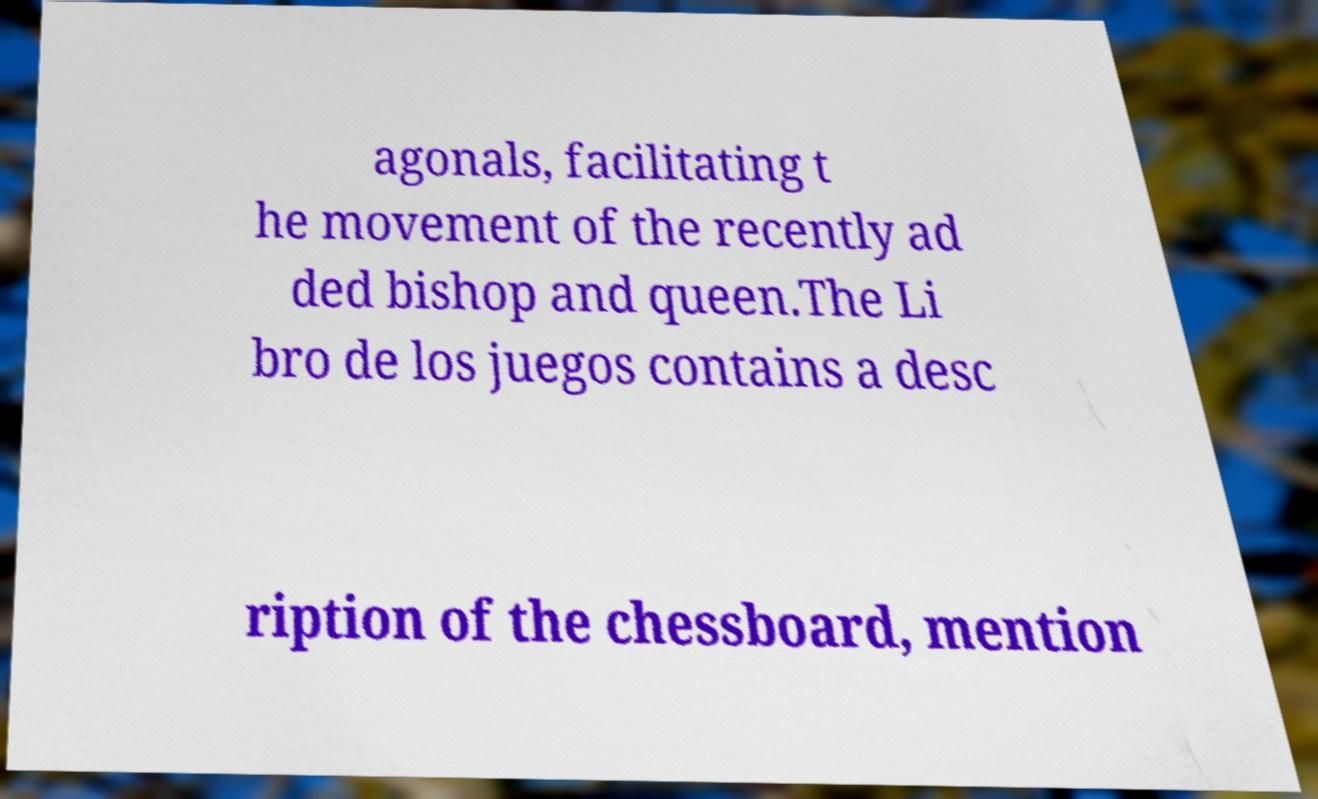Could you extract and type out the text from this image? agonals, facilitating t he movement of the recently ad ded bishop and queen.The Li bro de los juegos contains a desc ription of the chessboard, mention 